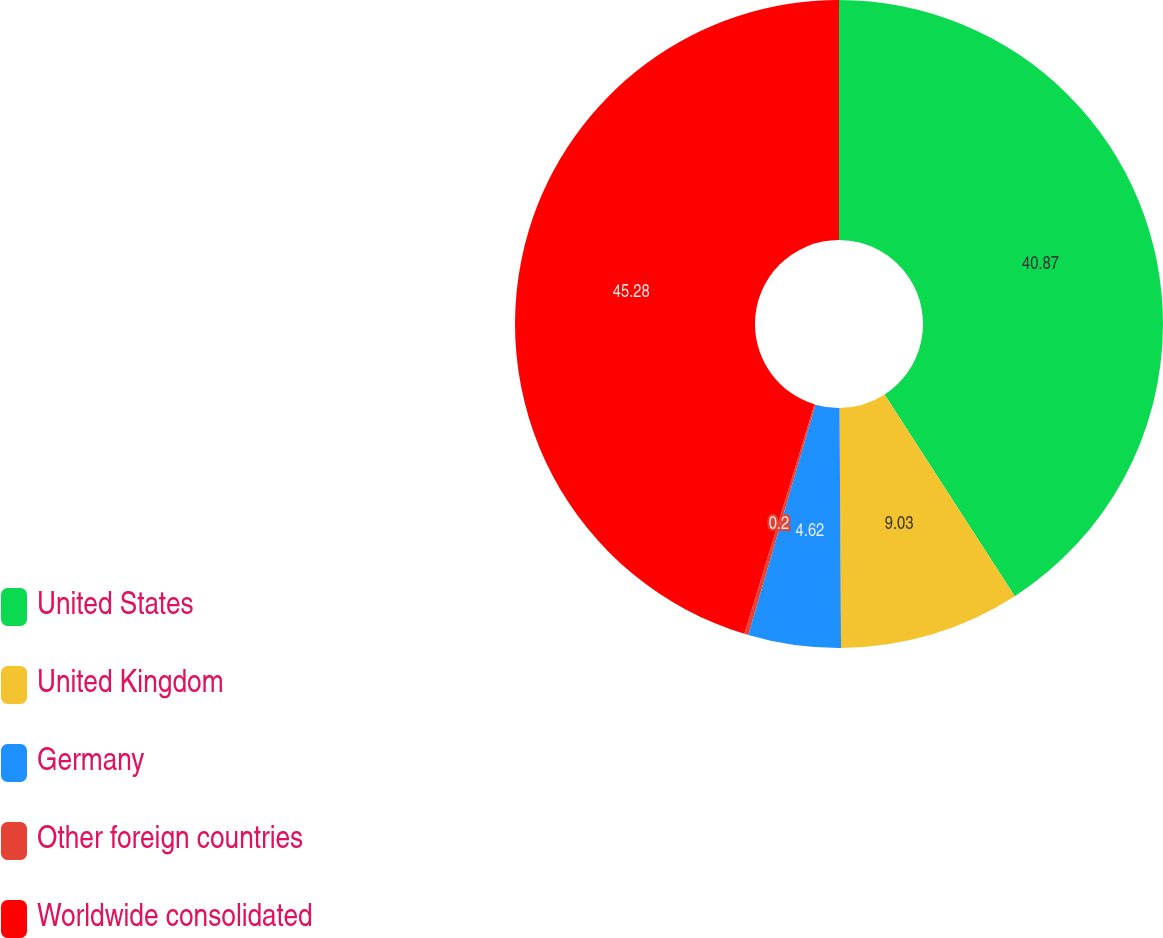Convert chart. <chart><loc_0><loc_0><loc_500><loc_500><pie_chart><fcel>United States<fcel>United Kingdom<fcel>Germany<fcel>Other foreign countries<fcel>Worldwide consolidated<nl><fcel>40.87%<fcel>9.03%<fcel>4.62%<fcel>0.2%<fcel>45.28%<nl></chart> 